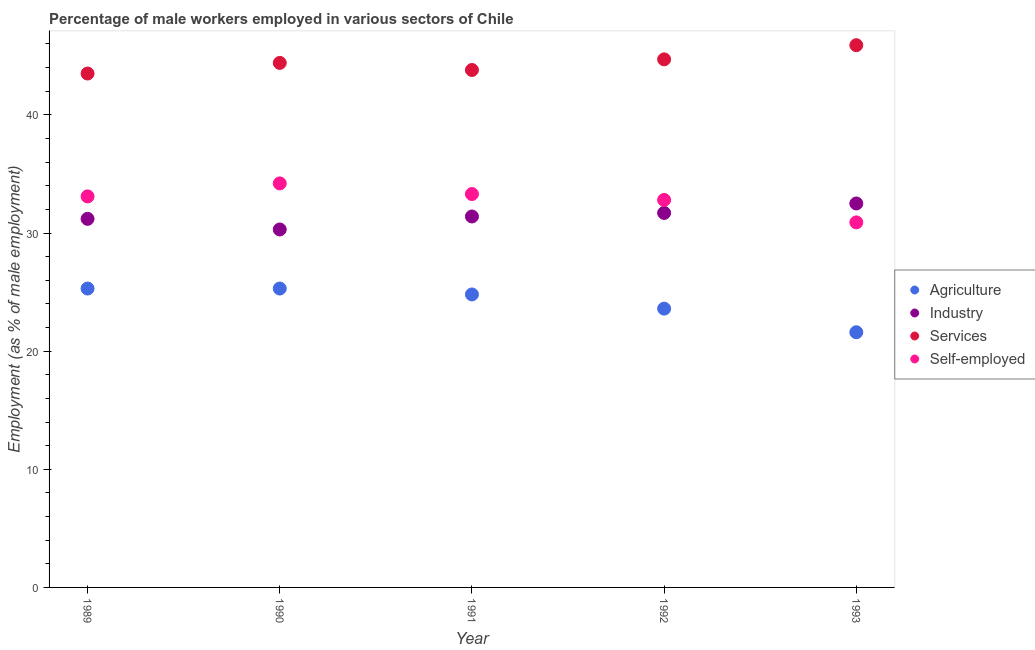How many different coloured dotlines are there?
Provide a succinct answer. 4. Is the number of dotlines equal to the number of legend labels?
Provide a short and direct response. Yes. What is the percentage of male workers in industry in 1993?
Keep it short and to the point. 32.5. Across all years, what is the maximum percentage of self employed male workers?
Give a very brief answer. 34.2. Across all years, what is the minimum percentage of self employed male workers?
Provide a succinct answer. 30.9. In which year was the percentage of male workers in services minimum?
Give a very brief answer. 1989. What is the total percentage of male workers in agriculture in the graph?
Keep it short and to the point. 120.6. What is the difference between the percentage of self employed male workers in 1990 and that in 1992?
Ensure brevity in your answer.  1.4. What is the difference between the percentage of male workers in industry in 1993 and the percentage of male workers in agriculture in 1990?
Ensure brevity in your answer.  7.2. What is the average percentage of self employed male workers per year?
Give a very brief answer. 32.86. In the year 1989, what is the difference between the percentage of male workers in services and percentage of self employed male workers?
Give a very brief answer. 10.4. In how many years, is the percentage of male workers in services greater than 22 %?
Your response must be concise. 5. What is the ratio of the percentage of male workers in services in 1991 to that in 1993?
Ensure brevity in your answer.  0.95. What is the difference between the highest and the second highest percentage of male workers in services?
Offer a very short reply. 1.2. What is the difference between the highest and the lowest percentage of male workers in industry?
Make the answer very short. 2.2. Is the percentage of self employed male workers strictly greater than the percentage of male workers in agriculture over the years?
Keep it short and to the point. Yes. How many dotlines are there?
Your answer should be very brief. 4. Does the graph contain grids?
Offer a very short reply. No. Where does the legend appear in the graph?
Give a very brief answer. Center right. How many legend labels are there?
Your answer should be very brief. 4. How are the legend labels stacked?
Keep it short and to the point. Vertical. What is the title of the graph?
Provide a short and direct response. Percentage of male workers employed in various sectors of Chile. Does "Offering training" appear as one of the legend labels in the graph?
Give a very brief answer. No. What is the label or title of the Y-axis?
Offer a very short reply. Employment (as % of male employment). What is the Employment (as % of male employment) of Agriculture in 1989?
Give a very brief answer. 25.3. What is the Employment (as % of male employment) in Industry in 1989?
Provide a succinct answer. 31.2. What is the Employment (as % of male employment) in Services in 1989?
Your answer should be compact. 43.5. What is the Employment (as % of male employment) of Self-employed in 1989?
Offer a very short reply. 33.1. What is the Employment (as % of male employment) of Agriculture in 1990?
Offer a very short reply. 25.3. What is the Employment (as % of male employment) in Industry in 1990?
Your response must be concise. 30.3. What is the Employment (as % of male employment) in Services in 1990?
Offer a very short reply. 44.4. What is the Employment (as % of male employment) in Self-employed in 1990?
Your answer should be very brief. 34.2. What is the Employment (as % of male employment) of Agriculture in 1991?
Your answer should be compact. 24.8. What is the Employment (as % of male employment) of Industry in 1991?
Keep it short and to the point. 31.4. What is the Employment (as % of male employment) of Services in 1991?
Provide a succinct answer. 43.8. What is the Employment (as % of male employment) in Self-employed in 1991?
Keep it short and to the point. 33.3. What is the Employment (as % of male employment) of Agriculture in 1992?
Provide a succinct answer. 23.6. What is the Employment (as % of male employment) in Industry in 1992?
Your answer should be very brief. 31.7. What is the Employment (as % of male employment) of Services in 1992?
Your response must be concise. 44.7. What is the Employment (as % of male employment) in Self-employed in 1992?
Your response must be concise. 32.8. What is the Employment (as % of male employment) of Agriculture in 1993?
Keep it short and to the point. 21.6. What is the Employment (as % of male employment) in Industry in 1993?
Provide a succinct answer. 32.5. What is the Employment (as % of male employment) in Services in 1993?
Provide a short and direct response. 45.9. What is the Employment (as % of male employment) of Self-employed in 1993?
Your answer should be very brief. 30.9. Across all years, what is the maximum Employment (as % of male employment) in Agriculture?
Provide a succinct answer. 25.3. Across all years, what is the maximum Employment (as % of male employment) in Industry?
Give a very brief answer. 32.5. Across all years, what is the maximum Employment (as % of male employment) in Services?
Give a very brief answer. 45.9. Across all years, what is the maximum Employment (as % of male employment) of Self-employed?
Ensure brevity in your answer.  34.2. Across all years, what is the minimum Employment (as % of male employment) in Agriculture?
Provide a succinct answer. 21.6. Across all years, what is the minimum Employment (as % of male employment) of Industry?
Your answer should be compact. 30.3. Across all years, what is the minimum Employment (as % of male employment) of Services?
Keep it short and to the point. 43.5. Across all years, what is the minimum Employment (as % of male employment) of Self-employed?
Ensure brevity in your answer.  30.9. What is the total Employment (as % of male employment) of Agriculture in the graph?
Your answer should be compact. 120.6. What is the total Employment (as % of male employment) of Industry in the graph?
Offer a terse response. 157.1. What is the total Employment (as % of male employment) of Services in the graph?
Your response must be concise. 222.3. What is the total Employment (as % of male employment) of Self-employed in the graph?
Your response must be concise. 164.3. What is the difference between the Employment (as % of male employment) of Agriculture in 1989 and that in 1990?
Ensure brevity in your answer.  0. What is the difference between the Employment (as % of male employment) of Industry in 1989 and that in 1990?
Provide a succinct answer. 0.9. What is the difference between the Employment (as % of male employment) of Agriculture in 1989 and that in 1991?
Your response must be concise. 0.5. What is the difference between the Employment (as % of male employment) in Industry in 1989 and that in 1991?
Offer a terse response. -0.2. What is the difference between the Employment (as % of male employment) of Services in 1989 and that in 1991?
Ensure brevity in your answer.  -0.3. What is the difference between the Employment (as % of male employment) of Self-employed in 1989 and that in 1991?
Give a very brief answer. -0.2. What is the difference between the Employment (as % of male employment) of Agriculture in 1989 and that in 1992?
Make the answer very short. 1.7. What is the difference between the Employment (as % of male employment) in Industry in 1989 and that in 1992?
Give a very brief answer. -0.5. What is the difference between the Employment (as % of male employment) in Services in 1989 and that in 1992?
Give a very brief answer. -1.2. What is the difference between the Employment (as % of male employment) in Agriculture in 1989 and that in 1993?
Your answer should be compact. 3.7. What is the difference between the Employment (as % of male employment) in Services in 1989 and that in 1993?
Your answer should be compact. -2.4. What is the difference between the Employment (as % of male employment) in Self-employed in 1990 and that in 1991?
Offer a terse response. 0.9. What is the difference between the Employment (as % of male employment) of Industry in 1990 and that in 1992?
Your response must be concise. -1.4. What is the difference between the Employment (as % of male employment) in Self-employed in 1990 and that in 1992?
Provide a short and direct response. 1.4. What is the difference between the Employment (as % of male employment) in Agriculture in 1990 and that in 1993?
Provide a succinct answer. 3.7. What is the difference between the Employment (as % of male employment) in Services in 1991 and that in 1992?
Keep it short and to the point. -0.9. What is the difference between the Employment (as % of male employment) of Self-employed in 1991 and that in 1992?
Provide a short and direct response. 0.5. What is the difference between the Employment (as % of male employment) of Agriculture in 1991 and that in 1993?
Your answer should be very brief. 3.2. What is the difference between the Employment (as % of male employment) in Industry in 1991 and that in 1993?
Ensure brevity in your answer.  -1.1. What is the difference between the Employment (as % of male employment) of Self-employed in 1991 and that in 1993?
Your answer should be very brief. 2.4. What is the difference between the Employment (as % of male employment) in Agriculture in 1992 and that in 1993?
Ensure brevity in your answer.  2. What is the difference between the Employment (as % of male employment) of Services in 1992 and that in 1993?
Ensure brevity in your answer.  -1.2. What is the difference between the Employment (as % of male employment) of Self-employed in 1992 and that in 1993?
Your answer should be very brief. 1.9. What is the difference between the Employment (as % of male employment) in Agriculture in 1989 and the Employment (as % of male employment) in Services in 1990?
Your answer should be compact. -19.1. What is the difference between the Employment (as % of male employment) in Agriculture in 1989 and the Employment (as % of male employment) in Self-employed in 1990?
Keep it short and to the point. -8.9. What is the difference between the Employment (as % of male employment) in Industry in 1989 and the Employment (as % of male employment) in Services in 1990?
Ensure brevity in your answer.  -13.2. What is the difference between the Employment (as % of male employment) in Industry in 1989 and the Employment (as % of male employment) in Self-employed in 1990?
Provide a short and direct response. -3. What is the difference between the Employment (as % of male employment) in Agriculture in 1989 and the Employment (as % of male employment) in Industry in 1991?
Offer a very short reply. -6.1. What is the difference between the Employment (as % of male employment) in Agriculture in 1989 and the Employment (as % of male employment) in Services in 1991?
Provide a succinct answer. -18.5. What is the difference between the Employment (as % of male employment) of Agriculture in 1989 and the Employment (as % of male employment) of Self-employed in 1991?
Offer a very short reply. -8. What is the difference between the Employment (as % of male employment) in Industry in 1989 and the Employment (as % of male employment) in Services in 1991?
Your response must be concise. -12.6. What is the difference between the Employment (as % of male employment) in Agriculture in 1989 and the Employment (as % of male employment) in Services in 1992?
Your answer should be compact. -19.4. What is the difference between the Employment (as % of male employment) in Agriculture in 1989 and the Employment (as % of male employment) in Self-employed in 1992?
Keep it short and to the point. -7.5. What is the difference between the Employment (as % of male employment) of Industry in 1989 and the Employment (as % of male employment) of Services in 1992?
Provide a succinct answer. -13.5. What is the difference between the Employment (as % of male employment) in Services in 1989 and the Employment (as % of male employment) in Self-employed in 1992?
Provide a succinct answer. 10.7. What is the difference between the Employment (as % of male employment) in Agriculture in 1989 and the Employment (as % of male employment) in Services in 1993?
Your response must be concise. -20.6. What is the difference between the Employment (as % of male employment) of Industry in 1989 and the Employment (as % of male employment) of Services in 1993?
Offer a terse response. -14.7. What is the difference between the Employment (as % of male employment) of Industry in 1989 and the Employment (as % of male employment) of Self-employed in 1993?
Your answer should be very brief. 0.3. What is the difference between the Employment (as % of male employment) in Agriculture in 1990 and the Employment (as % of male employment) in Industry in 1991?
Your answer should be very brief. -6.1. What is the difference between the Employment (as % of male employment) in Agriculture in 1990 and the Employment (as % of male employment) in Services in 1991?
Provide a succinct answer. -18.5. What is the difference between the Employment (as % of male employment) in Industry in 1990 and the Employment (as % of male employment) in Services in 1991?
Make the answer very short. -13.5. What is the difference between the Employment (as % of male employment) of Industry in 1990 and the Employment (as % of male employment) of Self-employed in 1991?
Make the answer very short. -3. What is the difference between the Employment (as % of male employment) in Agriculture in 1990 and the Employment (as % of male employment) in Industry in 1992?
Provide a short and direct response. -6.4. What is the difference between the Employment (as % of male employment) in Agriculture in 1990 and the Employment (as % of male employment) in Services in 1992?
Give a very brief answer. -19.4. What is the difference between the Employment (as % of male employment) of Industry in 1990 and the Employment (as % of male employment) of Services in 1992?
Offer a terse response. -14.4. What is the difference between the Employment (as % of male employment) in Industry in 1990 and the Employment (as % of male employment) in Self-employed in 1992?
Offer a terse response. -2.5. What is the difference between the Employment (as % of male employment) of Agriculture in 1990 and the Employment (as % of male employment) of Services in 1993?
Offer a terse response. -20.6. What is the difference between the Employment (as % of male employment) of Industry in 1990 and the Employment (as % of male employment) of Services in 1993?
Make the answer very short. -15.6. What is the difference between the Employment (as % of male employment) of Services in 1990 and the Employment (as % of male employment) of Self-employed in 1993?
Make the answer very short. 13.5. What is the difference between the Employment (as % of male employment) in Agriculture in 1991 and the Employment (as % of male employment) in Industry in 1992?
Your answer should be compact. -6.9. What is the difference between the Employment (as % of male employment) of Agriculture in 1991 and the Employment (as % of male employment) of Services in 1992?
Give a very brief answer. -19.9. What is the difference between the Employment (as % of male employment) of Agriculture in 1991 and the Employment (as % of male employment) of Self-employed in 1992?
Provide a succinct answer. -8. What is the difference between the Employment (as % of male employment) of Agriculture in 1991 and the Employment (as % of male employment) of Industry in 1993?
Offer a terse response. -7.7. What is the difference between the Employment (as % of male employment) of Agriculture in 1991 and the Employment (as % of male employment) of Services in 1993?
Offer a terse response. -21.1. What is the difference between the Employment (as % of male employment) of Industry in 1991 and the Employment (as % of male employment) of Services in 1993?
Your answer should be compact. -14.5. What is the difference between the Employment (as % of male employment) in Industry in 1991 and the Employment (as % of male employment) in Self-employed in 1993?
Your answer should be compact. 0.5. What is the difference between the Employment (as % of male employment) in Services in 1991 and the Employment (as % of male employment) in Self-employed in 1993?
Provide a succinct answer. 12.9. What is the difference between the Employment (as % of male employment) in Agriculture in 1992 and the Employment (as % of male employment) in Services in 1993?
Your answer should be compact. -22.3. What is the average Employment (as % of male employment) of Agriculture per year?
Provide a short and direct response. 24.12. What is the average Employment (as % of male employment) of Industry per year?
Provide a short and direct response. 31.42. What is the average Employment (as % of male employment) of Services per year?
Provide a succinct answer. 44.46. What is the average Employment (as % of male employment) of Self-employed per year?
Make the answer very short. 32.86. In the year 1989, what is the difference between the Employment (as % of male employment) of Agriculture and Employment (as % of male employment) of Services?
Offer a terse response. -18.2. In the year 1989, what is the difference between the Employment (as % of male employment) of Services and Employment (as % of male employment) of Self-employed?
Make the answer very short. 10.4. In the year 1990, what is the difference between the Employment (as % of male employment) of Agriculture and Employment (as % of male employment) of Industry?
Your answer should be compact. -5. In the year 1990, what is the difference between the Employment (as % of male employment) in Agriculture and Employment (as % of male employment) in Services?
Provide a short and direct response. -19.1. In the year 1990, what is the difference between the Employment (as % of male employment) in Industry and Employment (as % of male employment) in Services?
Ensure brevity in your answer.  -14.1. In the year 1990, what is the difference between the Employment (as % of male employment) of Services and Employment (as % of male employment) of Self-employed?
Give a very brief answer. 10.2. In the year 1991, what is the difference between the Employment (as % of male employment) of Agriculture and Employment (as % of male employment) of Services?
Keep it short and to the point. -19. In the year 1991, what is the difference between the Employment (as % of male employment) of Agriculture and Employment (as % of male employment) of Self-employed?
Offer a very short reply. -8.5. In the year 1991, what is the difference between the Employment (as % of male employment) of Industry and Employment (as % of male employment) of Self-employed?
Make the answer very short. -1.9. In the year 1992, what is the difference between the Employment (as % of male employment) in Agriculture and Employment (as % of male employment) in Services?
Offer a very short reply. -21.1. In the year 1992, what is the difference between the Employment (as % of male employment) in Industry and Employment (as % of male employment) in Services?
Provide a succinct answer. -13. In the year 1992, what is the difference between the Employment (as % of male employment) of Industry and Employment (as % of male employment) of Self-employed?
Your response must be concise. -1.1. In the year 1993, what is the difference between the Employment (as % of male employment) in Agriculture and Employment (as % of male employment) in Services?
Give a very brief answer. -24.3. In the year 1993, what is the difference between the Employment (as % of male employment) in Agriculture and Employment (as % of male employment) in Self-employed?
Offer a terse response. -9.3. In the year 1993, what is the difference between the Employment (as % of male employment) of Industry and Employment (as % of male employment) of Services?
Offer a terse response. -13.4. In the year 1993, what is the difference between the Employment (as % of male employment) of Services and Employment (as % of male employment) of Self-employed?
Offer a terse response. 15. What is the ratio of the Employment (as % of male employment) of Agriculture in 1989 to that in 1990?
Make the answer very short. 1. What is the ratio of the Employment (as % of male employment) of Industry in 1989 to that in 1990?
Provide a succinct answer. 1.03. What is the ratio of the Employment (as % of male employment) of Services in 1989 to that in 1990?
Give a very brief answer. 0.98. What is the ratio of the Employment (as % of male employment) in Self-employed in 1989 to that in 1990?
Your response must be concise. 0.97. What is the ratio of the Employment (as % of male employment) in Agriculture in 1989 to that in 1991?
Ensure brevity in your answer.  1.02. What is the ratio of the Employment (as % of male employment) in Self-employed in 1989 to that in 1991?
Offer a terse response. 0.99. What is the ratio of the Employment (as % of male employment) in Agriculture in 1989 to that in 1992?
Ensure brevity in your answer.  1.07. What is the ratio of the Employment (as % of male employment) in Industry in 1989 to that in 1992?
Make the answer very short. 0.98. What is the ratio of the Employment (as % of male employment) in Services in 1989 to that in 1992?
Your response must be concise. 0.97. What is the ratio of the Employment (as % of male employment) of Self-employed in 1989 to that in 1992?
Your answer should be compact. 1.01. What is the ratio of the Employment (as % of male employment) of Agriculture in 1989 to that in 1993?
Your answer should be compact. 1.17. What is the ratio of the Employment (as % of male employment) of Services in 1989 to that in 1993?
Provide a succinct answer. 0.95. What is the ratio of the Employment (as % of male employment) in Self-employed in 1989 to that in 1993?
Your answer should be very brief. 1.07. What is the ratio of the Employment (as % of male employment) in Agriculture in 1990 to that in 1991?
Offer a terse response. 1.02. What is the ratio of the Employment (as % of male employment) of Industry in 1990 to that in 1991?
Offer a very short reply. 0.96. What is the ratio of the Employment (as % of male employment) of Services in 1990 to that in 1991?
Offer a terse response. 1.01. What is the ratio of the Employment (as % of male employment) in Agriculture in 1990 to that in 1992?
Provide a short and direct response. 1.07. What is the ratio of the Employment (as % of male employment) in Industry in 1990 to that in 1992?
Keep it short and to the point. 0.96. What is the ratio of the Employment (as % of male employment) in Self-employed in 1990 to that in 1992?
Offer a terse response. 1.04. What is the ratio of the Employment (as % of male employment) in Agriculture in 1990 to that in 1993?
Keep it short and to the point. 1.17. What is the ratio of the Employment (as % of male employment) of Industry in 1990 to that in 1993?
Your answer should be compact. 0.93. What is the ratio of the Employment (as % of male employment) in Services in 1990 to that in 1993?
Make the answer very short. 0.97. What is the ratio of the Employment (as % of male employment) in Self-employed in 1990 to that in 1993?
Provide a short and direct response. 1.11. What is the ratio of the Employment (as % of male employment) in Agriculture in 1991 to that in 1992?
Offer a very short reply. 1.05. What is the ratio of the Employment (as % of male employment) in Industry in 1991 to that in 1992?
Ensure brevity in your answer.  0.99. What is the ratio of the Employment (as % of male employment) in Services in 1991 to that in 1992?
Ensure brevity in your answer.  0.98. What is the ratio of the Employment (as % of male employment) in Self-employed in 1991 to that in 1992?
Offer a terse response. 1.02. What is the ratio of the Employment (as % of male employment) in Agriculture in 1991 to that in 1993?
Offer a very short reply. 1.15. What is the ratio of the Employment (as % of male employment) in Industry in 1991 to that in 1993?
Offer a terse response. 0.97. What is the ratio of the Employment (as % of male employment) of Services in 1991 to that in 1993?
Provide a succinct answer. 0.95. What is the ratio of the Employment (as % of male employment) in Self-employed in 1991 to that in 1993?
Your answer should be compact. 1.08. What is the ratio of the Employment (as % of male employment) in Agriculture in 1992 to that in 1993?
Your answer should be very brief. 1.09. What is the ratio of the Employment (as % of male employment) of Industry in 1992 to that in 1993?
Make the answer very short. 0.98. What is the ratio of the Employment (as % of male employment) in Services in 1992 to that in 1993?
Offer a very short reply. 0.97. What is the ratio of the Employment (as % of male employment) in Self-employed in 1992 to that in 1993?
Make the answer very short. 1.06. What is the difference between the highest and the second highest Employment (as % of male employment) of Industry?
Offer a terse response. 0.8. What is the difference between the highest and the second highest Employment (as % of male employment) in Self-employed?
Provide a succinct answer. 0.9. What is the difference between the highest and the lowest Employment (as % of male employment) in Industry?
Give a very brief answer. 2.2. What is the difference between the highest and the lowest Employment (as % of male employment) of Self-employed?
Your response must be concise. 3.3. 